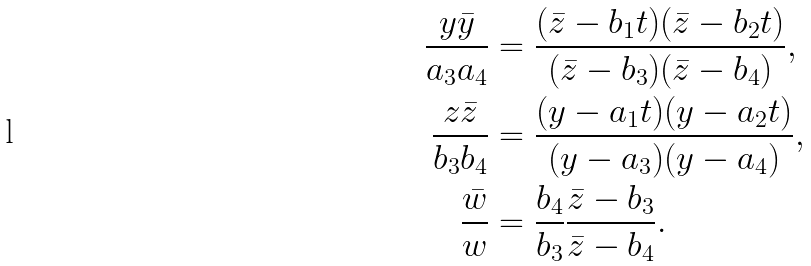Convert formula to latex. <formula><loc_0><loc_0><loc_500><loc_500>\frac { y \bar { y } } { a _ { 3 } a _ { 4 } } & = \frac { ( \bar { z } - b _ { 1 } t ) ( \bar { z } - b _ { 2 } t ) } { ( \bar { z } - b _ { 3 } ) ( \bar { z } - b _ { 4 } ) } , \\ \frac { z \bar { z } } { b _ { 3 } b _ { 4 } } & = \frac { ( y - a _ { 1 } t ) ( y - a _ { 2 } t ) } { ( y - a _ { 3 } ) ( y - a _ { 4 } ) } , \\ \frac { \bar { w } } { w } & = \frac { b _ { 4 } } { b _ { 3 } } \frac { \bar { z } - b _ { 3 } } { \bar { z } - b _ { 4 } } .</formula> 